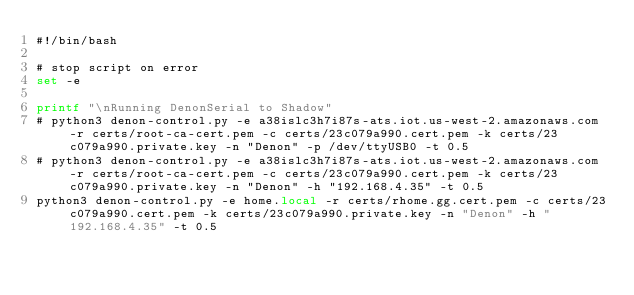Convert code to text. <code><loc_0><loc_0><loc_500><loc_500><_Bash_>#!/bin/bash

# stop script on error
set -e

printf "\nRunning DenonSerial to Shadow"
# python3 denon-control.py -e a38islc3h7i87s-ats.iot.us-west-2.amazonaws.com -r certs/root-ca-cert.pem -c certs/23c079a990.cert.pem -k certs/23c079a990.private.key -n "Denon" -p /dev/ttyUSB0 -t 0.5
# python3 denon-control.py -e a38islc3h7i87s-ats.iot.us-west-2.amazonaws.com -r certs/root-ca-cert.pem -c certs/23c079a990.cert.pem -k certs/23c079a990.private.key -n "Denon" -h "192.168.4.35" -t 0.5
python3 denon-control.py -e home.local -r certs/rhome.gg.cert.pem -c certs/23c079a990.cert.pem -k certs/23c079a990.private.key -n "Denon" -h "192.168.4.35" -t 0.5
</code> 